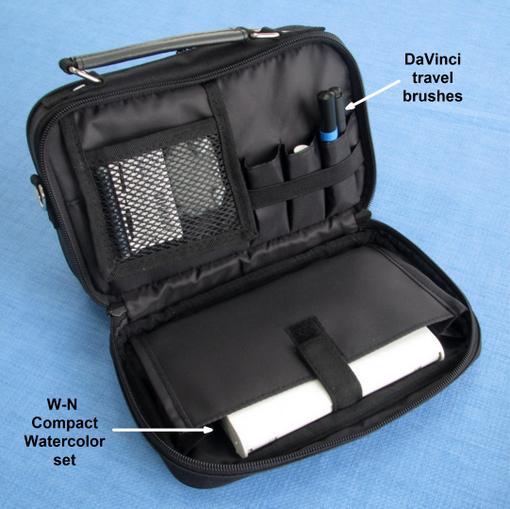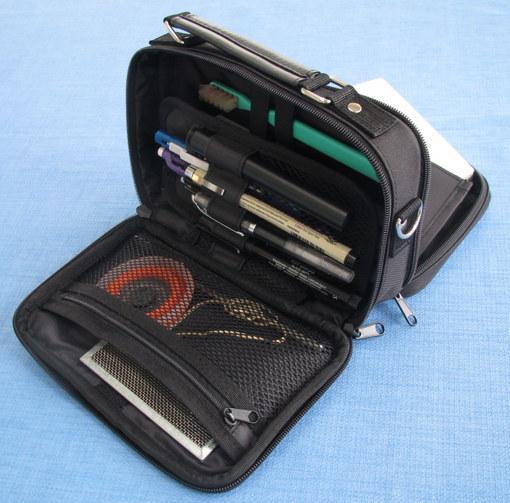The first image is the image on the left, the second image is the image on the right. Considering the images on both sides, is "At least two of the cases are open." valid? Answer yes or no. Yes. 